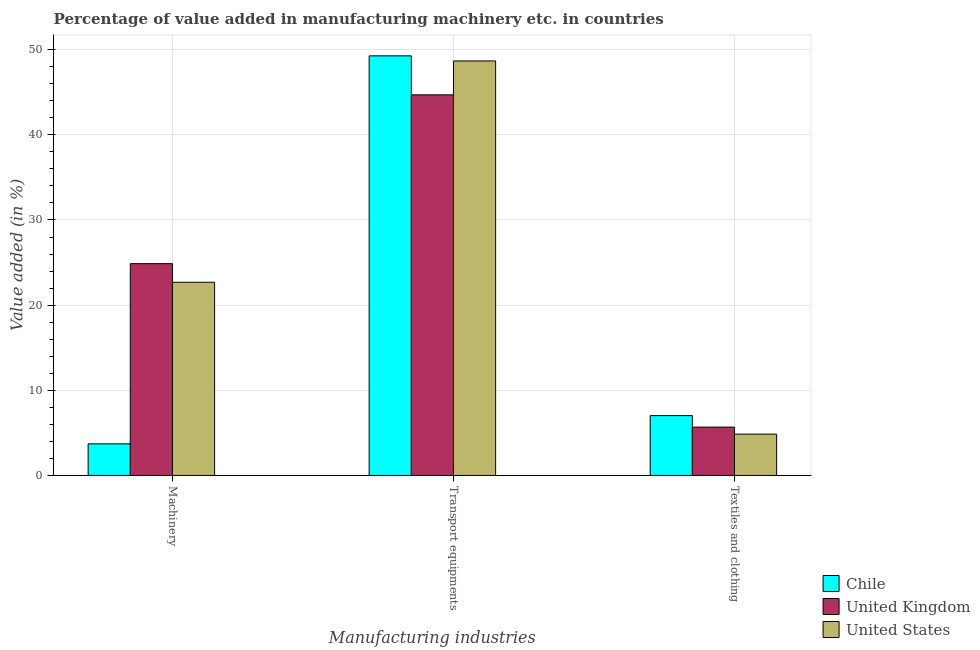How many different coloured bars are there?
Provide a succinct answer. 3. Are the number of bars per tick equal to the number of legend labels?
Your response must be concise. Yes. What is the label of the 1st group of bars from the left?
Offer a terse response. Machinery. What is the value added in manufacturing textile and clothing in United Kingdom?
Your answer should be very brief. 5.68. Across all countries, what is the maximum value added in manufacturing textile and clothing?
Ensure brevity in your answer.  7.03. Across all countries, what is the minimum value added in manufacturing machinery?
Keep it short and to the point. 3.71. In which country was the value added in manufacturing machinery minimum?
Give a very brief answer. Chile. What is the total value added in manufacturing machinery in the graph?
Offer a very short reply. 51.27. What is the difference between the value added in manufacturing transport equipments in United Kingdom and that in United States?
Offer a terse response. -3.98. What is the difference between the value added in manufacturing machinery in United States and the value added in manufacturing textile and clothing in Chile?
Your answer should be compact. 15.66. What is the average value added in manufacturing textile and clothing per country?
Your answer should be very brief. 5.85. What is the difference between the value added in manufacturing transport equipments and value added in manufacturing machinery in United Kingdom?
Ensure brevity in your answer.  19.83. What is the ratio of the value added in manufacturing machinery in Chile to that in United Kingdom?
Your answer should be very brief. 0.15. Is the value added in manufacturing machinery in United States less than that in United Kingdom?
Offer a terse response. Yes. What is the difference between the highest and the second highest value added in manufacturing textile and clothing?
Your answer should be compact. 1.35. What is the difference between the highest and the lowest value added in manufacturing transport equipments?
Your answer should be very brief. 4.58. Is the sum of the value added in manufacturing textile and clothing in United Kingdom and Chile greater than the maximum value added in manufacturing transport equipments across all countries?
Give a very brief answer. No. What does the 1st bar from the left in Machinery represents?
Keep it short and to the point. Chile. What does the 1st bar from the right in Transport equipments represents?
Make the answer very short. United States. How many bars are there?
Give a very brief answer. 9. Are the values on the major ticks of Y-axis written in scientific E-notation?
Your response must be concise. No. Does the graph contain any zero values?
Provide a succinct answer. No. Where does the legend appear in the graph?
Your response must be concise. Bottom right. How are the legend labels stacked?
Offer a terse response. Vertical. What is the title of the graph?
Your answer should be very brief. Percentage of value added in manufacturing machinery etc. in countries. Does "Armenia" appear as one of the legend labels in the graph?
Give a very brief answer. No. What is the label or title of the X-axis?
Provide a short and direct response. Manufacturing industries. What is the label or title of the Y-axis?
Provide a succinct answer. Value added (in %). What is the Value added (in %) in Chile in Machinery?
Your answer should be very brief. 3.71. What is the Value added (in %) in United Kingdom in Machinery?
Offer a very short reply. 24.87. What is the Value added (in %) of United States in Machinery?
Give a very brief answer. 22.69. What is the Value added (in %) of Chile in Transport equipments?
Your response must be concise. 49.28. What is the Value added (in %) in United Kingdom in Transport equipments?
Keep it short and to the point. 44.7. What is the Value added (in %) in United States in Transport equipments?
Offer a terse response. 48.68. What is the Value added (in %) in Chile in Textiles and clothing?
Give a very brief answer. 7.03. What is the Value added (in %) in United Kingdom in Textiles and clothing?
Offer a very short reply. 5.68. What is the Value added (in %) in United States in Textiles and clothing?
Ensure brevity in your answer.  4.86. Across all Manufacturing industries, what is the maximum Value added (in %) in Chile?
Offer a terse response. 49.28. Across all Manufacturing industries, what is the maximum Value added (in %) in United Kingdom?
Give a very brief answer. 44.7. Across all Manufacturing industries, what is the maximum Value added (in %) in United States?
Provide a short and direct response. 48.68. Across all Manufacturing industries, what is the minimum Value added (in %) of Chile?
Your answer should be very brief. 3.71. Across all Manufacturing industries, what is the minimum Value added (in %) of United Kingdom?
Your answer should be compact. 5.68. Across all Manufacturing industries, what is the minimum Value added (in %) in United States?
Your answer should be very brief. 4.86. What is the total Value added (in %) in Chile in the graph?
Provide a short and direct response. 60.01. What is the total Value added (in %) of United Kingdom in the graph?
Ensure brevity in your answer.  75.25. What is the total Value added (in %) in United States in the graph?
Your response must be concise. 76.22. What is the difference between the Value added (in %) in Chile in Machinery and that in Transport equipments?
Ensure brevity in your answer.  -45.57. What is the difference between the Value added (in %) in United Kingdom in Machinery and that in Transport equipments?
Ensure brevity in your answer.  -19.83. What is the difference between the Value added (in %) of United States in Machinery and that in Transport equipments?
Your answer should be compact. -25.99. What is the difference between the Value added (in %) in Chile in Machinery and that in Textiles and clothing?
Provide a short and direct response. -3.32. What is the difference between the Value added (in %) in United Kingdom in Machinery and that in Textiles and clothing?
Give a very brief answer. 19.2. What is the difference between the Value added (in %) in United States in Machinery and that in Textiles and clothing?
Ensure brevity in your answer.  17.83. What is the difference between the Value added (in %) of Chile in Transport equipments and that in Textiles and clothing?
Provide a short and direct response. 42.25. What is the difference between the Value added (in %) in United Kingdom in Transport equipments and that in Textiles and clothing?
Keep it short and to the point. 39.02. What is the difference between the Value added (in %) in United States in Transport equipments and that in Textiles and clothing?
Ensure brevity in your answer.  43.82. What is the difference between the Value added (in %) in Chile in Machinery and the Value added (in %) in United Kingdom in Transport equipments?
Offer a terse response. -40.99. What is the difference between the Value added (in %) of Chile in Machinery and the Value added (in %) of United States in Transport equipments?
Make the answer very short. -44.97. What is the difference between the Value added (in %) in United Kingdom in Machinery and the Value added (in %) in United States in Transport equipments?
Ensure brevity in your answer.  -23.81. What is the difference between the Value added (in %) in Chile in Machinery and the Value added (in %) in United Kingdom in Textiles and clothing?
Offer a very short reply. -1.97. What is the difference between the Value added (in %) of Chile in Machinery and the Value added (in %) of United States in Textiles and clothing?
Give a very brief answer. -1.15. What is the difference between the Value added (in %) in United Kingdom in Machinery and the Value added (in %) in United States in Textiles and clothing?
Offer a terse response. 20.02. What is the difference between the Value added (in %) in Chile in Transport equipments and the Value added (in %) in United Kingdom in Textiles and clothing?
Your response must be concise. 43.6. What is the difference between the Value added (in %) in Chile in Transport equipments and the Value added (in %) in United States in Textiles and clothing?
Give a very brief answer. 44.42. What is the difference between the Value added (in %) of United Kingdom in Transport equipments and the Value added (in %) of United States in Textiles and clothing?
Your answer should be compact. 39.84. What is the average Value added (in %) of Chile per Manufacturing industries?
Provide a succinct answer. 20. What is the average Value added (in %) in United Kingdom per Manufacturing industries?
Your response must be concise. 25.08. What is the average Value added (in %) in United States per Manufacturing industries?
Offer a terse response. 25.41. What is the difference between the Value added (in %) of Chile and Value added (in %) of United Kingdom in Machinery?
Keep it short and to the point. -21.16. What is the difference between the Value added (in %) of Chile and Value added (in %) of United States in Machinery?
Make the answer very short. -18.98. What is the difference between the Value added (in %) of United Kingdom and Value added (in %) of United States in Machinery?
Provide a succinct answer. 2.19. What is the difference between the Value added (in %) of Chile and Value added (in %) of United Kingdom in Transport equipments?
Provide a succinct answer. 4.58. What is the difference between the Value added (in %) of Chile and Value added (in %) of United States in Transport equipments?
Offer a terse response. 0.6. What is the difference between the Value added (in %) of United Kingdom and Value added (in %) of United States in Transport equipments?
Keep it short and to the point. -3.98. What is the difference between the Value added (in %) of Chile and Value added (in %) of United Kingdom in Textiles and clothing?
Offer a very short reply. 1.35. What is the difference between the Value added (in %) of Chile and Value added (in %) of United States in Textiles and clothing?
Provide a short and direct response. 2.17. What is the difference between the Value added (in %) in United Kingdom and Value added (in %) in United States in Textiles and clothing?
Offer a very short reply. 0.82. What is the ratio of the Value added (in %) in Chile in Machinery to that in Transport equipments?
Your response must be concise. 0.08. What is the ratio of the Value added (in %) in United Kingdom in Machinery to that in Transport equipments?
Keep it short and to the point. 0.56. What is the ratio of the Value added (in %) of United States in Machinery to that in Transport equipments?
Offer a terse response. 0.47. What is the ratio of the Value added (in %) in Chile in Machinery to that in Textiles and clothing?
Keep it short and to the point. 0.53. What is the ratio of the Value added (in %) in United Kingdom in Machinery to that in Textiles and clothing?
Your answer should be compact. 4.38. What is the ratio of the Value added (in %) of United States in Machinery to that in Textiles and clothing?
Your answer should be very brief. 4.67. What is the ratio of the Value added (in %) of Chile in Transport equipments to that in Textiles and clothing?
Provide a short and direct response. 7.01. What is the ratio of the Value added (in %) in United Kingdom in Transport equipments to that in Textiles and clothing?
Make the answer very short. 7.87. What is the ratio of the Value added (in %) of United States in Transport equipments to that in Textiles and clothing?
Provide a succinct answer. 10.03. What is the difference between the highest and the second highest Value added (in %) of Chile?
Offer a very short reply. 42.25. What is the difference between the highest and the second highest Value added (in %) in United Kingdom?
Make the answer very short. 19.83. What is the difference between the highest and the second highest Value added (in %) of United States?
Your answer should be very brief. 25.99. What is the difference between the highest and the lowest Value added (in %) of Chile?
Provide a short and direct response. 45.57. What is the difference between the highest and the lowest Value added (in %) in United Kingdom?
Offer a very short reply. 39.02. What is the difference between the highest and the lowest Value added (in %) in United States?
Offer a terse response. 43.82. 